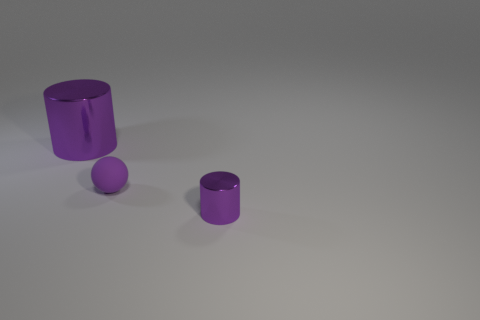How many other objects are the same color as the rubber sphere?
Your answer should be compact. 2. What number of purple objects are either small metal objects or spheres?
Your answer should be very brief. 2. The thing that is both in front of the big purple object and behind the small purple cylinder is what color?
Make the answer very short. Purple. Do the cylinder that is on the right side of the big purple metallic cylinder and the small thing behind the tiny cylinder have the same material?
Offer a very short reply. No. Is the number of small things on the right side of the small purple sphere greater than the number of purple matte spheres behind the big metallic cylinder?
Provide a short and direct response. Yes. There is a metal object that is the same size as the purple ball; what is its shape?
Offer a terse response. Cylinder. What number of things are big cubes or purple shiny objects on the right side of the small purple matte object?
Offer a very short reply. 1. How many big things are on the right side of the tiny purple shiny thing?
Your answer should be very brief. 0. What color is the small object that is the same material as the large cylinder?
Make the answer very short. Purple. What number of rubber things are either small cyan objects or big purple objects?
Keep it short and to the point. 0. 